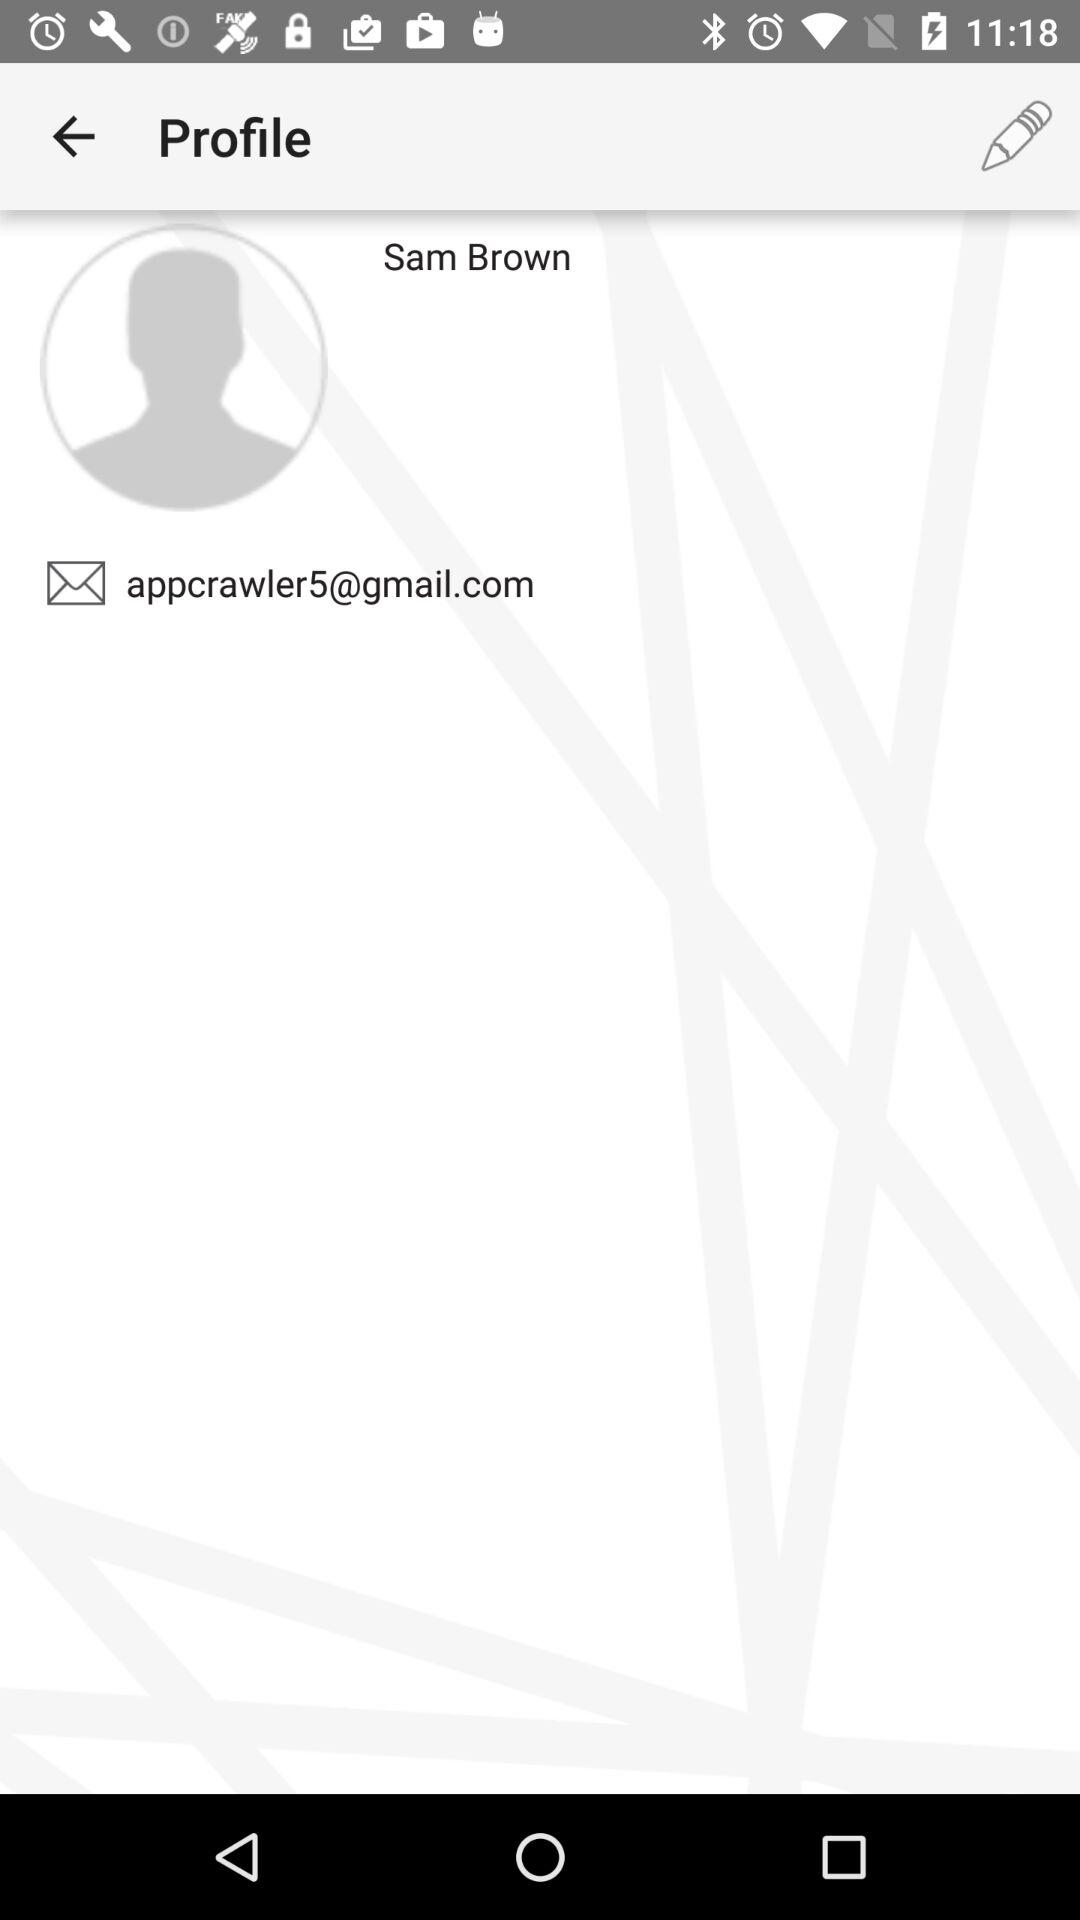What is the Gmail account address? The Gmail account address is appcrawler5@gmail.com. 